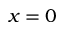<formula> <loc_0><loc_0><loc_500><loc_500>x = 0</formula> 